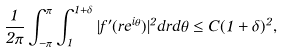<formula> <loc_0><loc_0><loc_500><loc_500>\frac { 1 } { 2 \pi } \int _ { - \pi } ^ { \pi } \int _ { 1 } ^ { 1 + \delta } | f ^ { \prime } ( r e ^ { i \theta } ) | ^ { 2 } d r d \theta \leq C ( 1 + \delta ) ^ { 2 } ,</formula> 